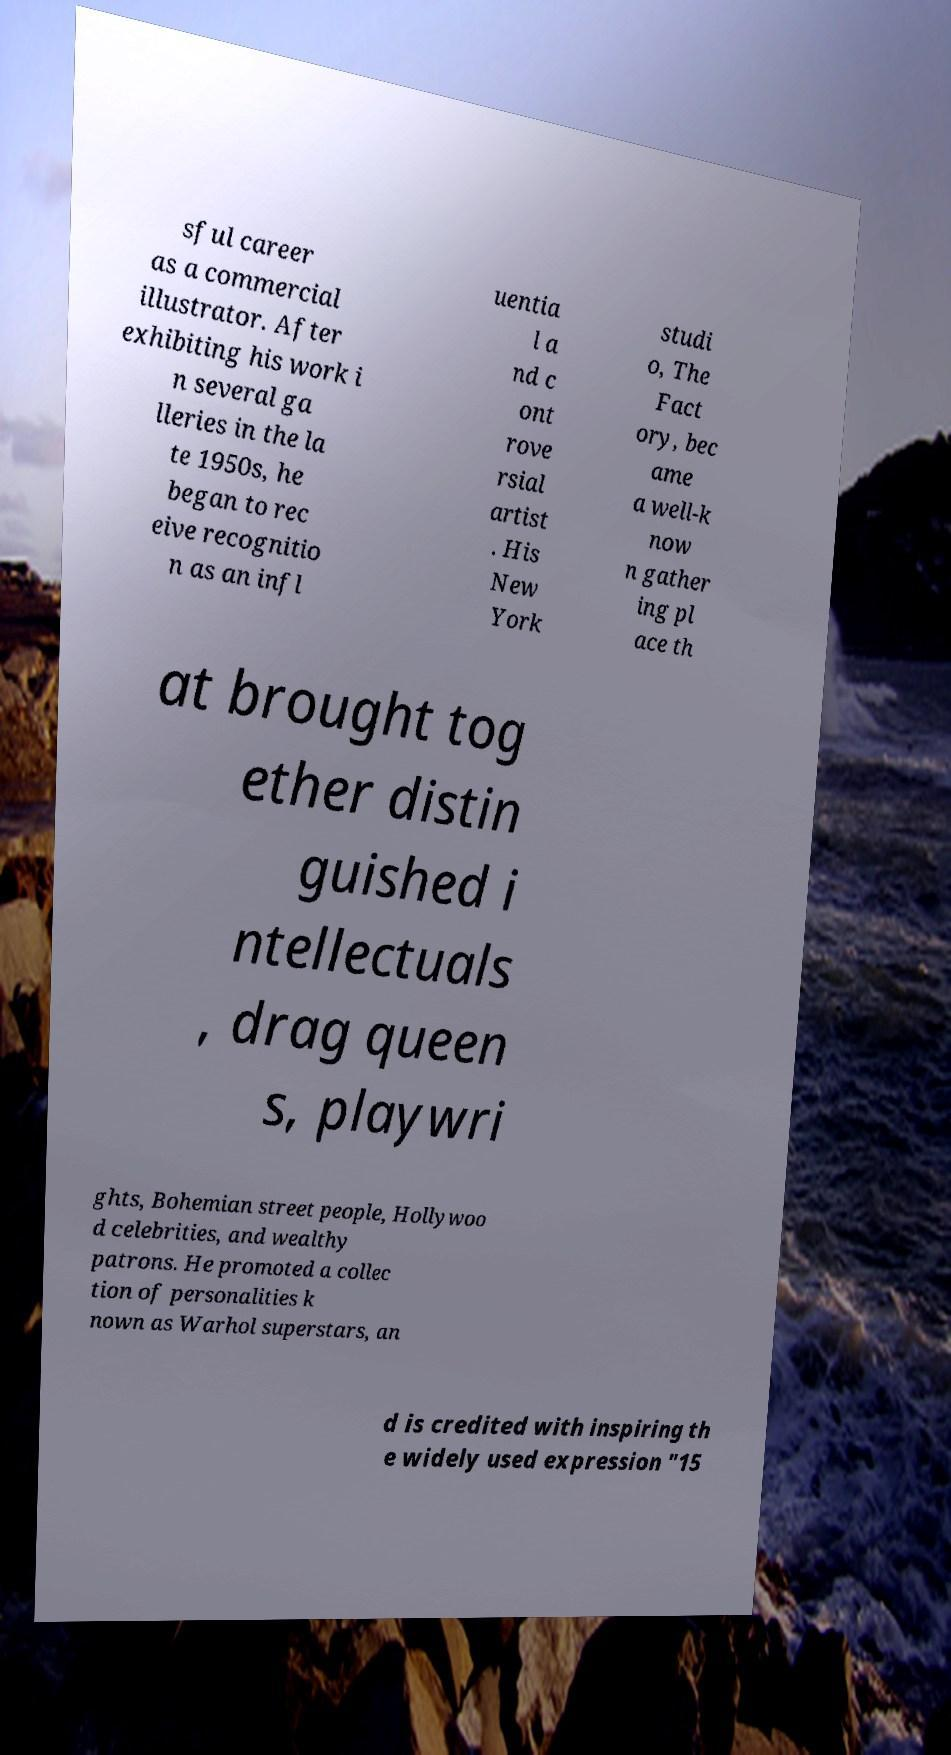For documentation purposes, I need the text within this image transcribed. Could you provide that? sful career as a commercial illustrator. After exhibiting his work i n several ga lleries in the la te 1950s, he began to rec eive recognitio n as an infl uentia l a nd c ont rove rsial artist . His New York studi o, The Fact ory, bec ame a well-k now n gather ing pl ace th at brought tog ether distin guished i ntellectuals , drag queen s, playwri ghts, Bohemian street people, Hollywoo d celebrities, and wealthy patrons. He promoted a collec tion of personalities k nown as Warhol superstars, an d is credited with inspiring th e widely used expression "15 